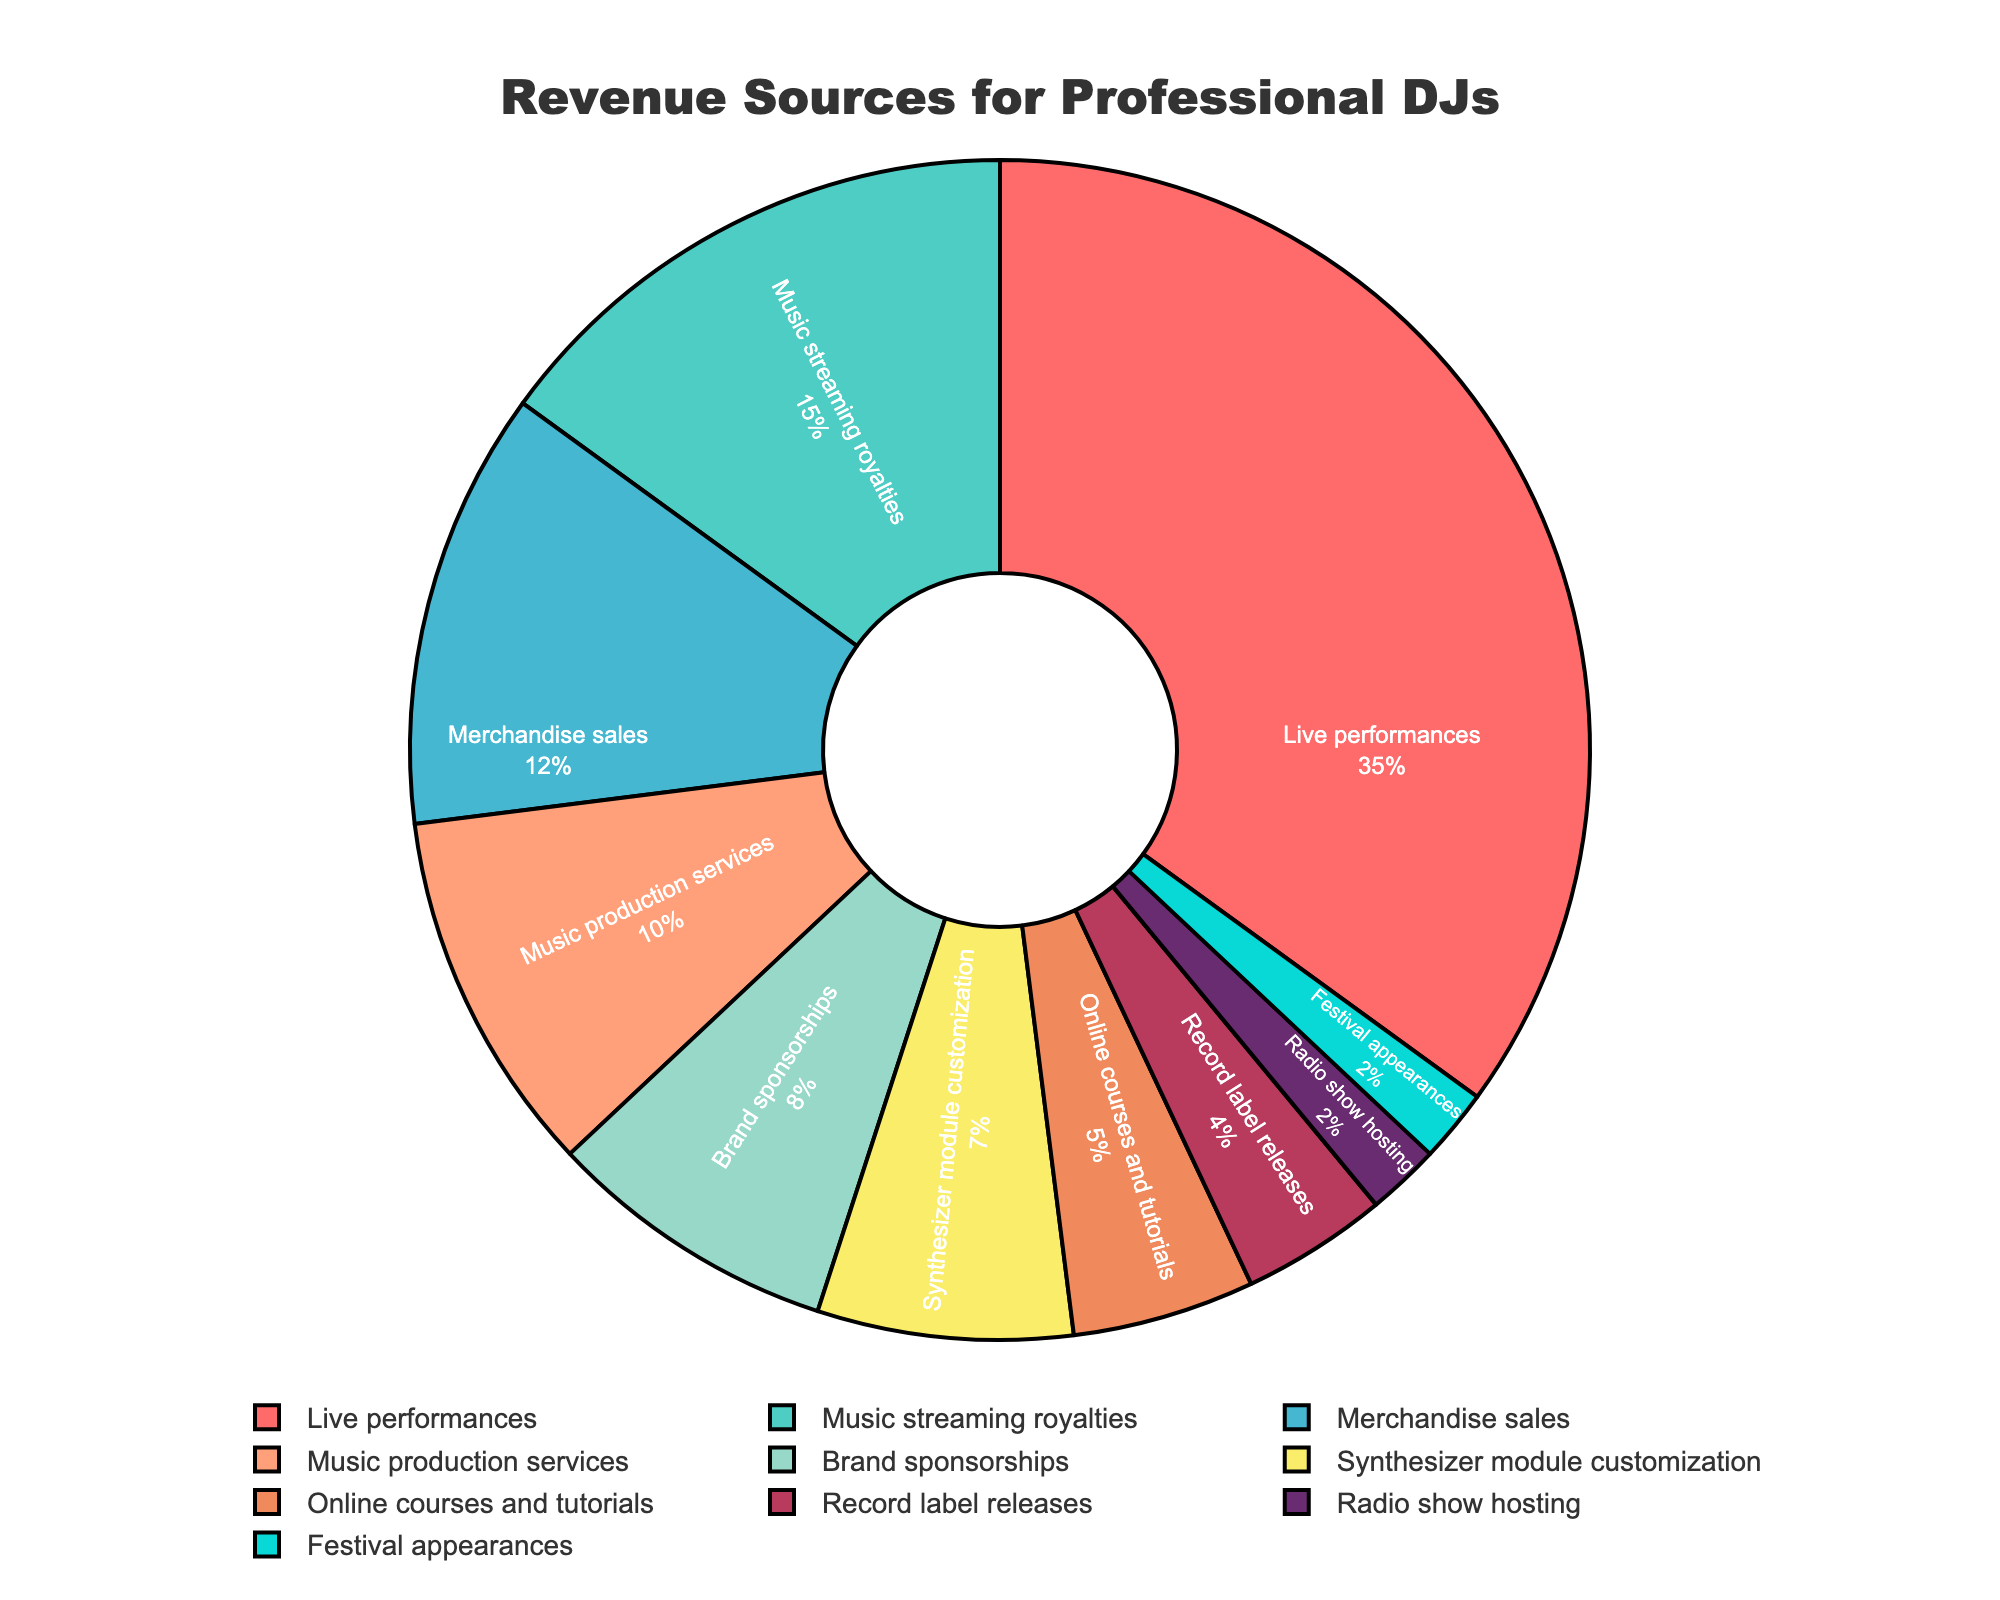What percentage of revenue comes from live performances? The figure shows that the category "Live performances" accounts for 35% of the total revenue.
Answer: 35% What are the combined revenue percentages for Music streaming royalties and Merchandise sales? The figure shows that "Music streaming royalties" is 15% and "Merchandise sales" is 12%. Adding these together gives 15% + 12% = 27%.
Answer: 27% How does the percentage of revenue from Music production services compare to Brand sponsorships? The chart shows that "Music production services" is at 10% while "Brand sponsorships" is at 8%. Therefore, Music production services generate 2% more revenue than Brand sponsorships.
Answer: Music production services generate 2% more Which revenue source contributes the least? The figure indicates "Radio show hosting" and "Festival appearances" each account for 2%, which are the smallest percentages in the chart.
Answer: Radio show hosting and Festival appearances What is the total percentage of revenue generated from Online courses and tutorials and Record label releases combined? The figure indicates "Online courses and tutorials" at 5% and "Record label releases" at 4%. Adding these together gives 5% + 4% = 9%.
Answer: 9% What revenue source is represented by the orange segment in the pie chart? By looking at the colors of the segments, the orange segment in the chart corresponds to "Brand sponsorships," which accounts for 8% of the revenue.
Answer: Brand sponsorships How much more revenue is generated from Synthesizer module customization compared to Festival appearances? The chart shows "Synthesizer module customization" at 7% and "Festival appearances" at 2%. Subtracting these values gives 7% - 2% = 5%.
Answer: 5% What is the total percentage of revenue from all sources except Live performances and Music streaming royalties? Live performances and Music streaming royalties together make up 35% + 15% = 50%. Subtracting from 100% gives 100% - 50% = 50%.
Answer: 50% Which revenue sources have a smaller share than Merchandise sales but larger than Record label releases? The figure shows "Merchandise sales" at 12% and "Record label releases" at 4%. The categories that fall between these values are "Music production services" (10%), "Brand sponsorships" (8%), and "Synthesizer module customization" (7%).
Answer: Music production services, Brand sponsorships, Synthesizer module customization 